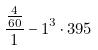<formula> <loc_0><loc_0><loc_500><loc_500>\frac { \frac { 4 } { 6 0 } } { 1 } - 1 ^ { 3 } \cdot 3 9 5</formula> 